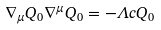<formula> <loc_0><loc_0><loc_500><loc_500>\nabla _ { \mu } Q _ { 0 } \nabla ^ { \mu } Q _ { 0 } = - \Lambda c Q _ { 0 }</formula> 